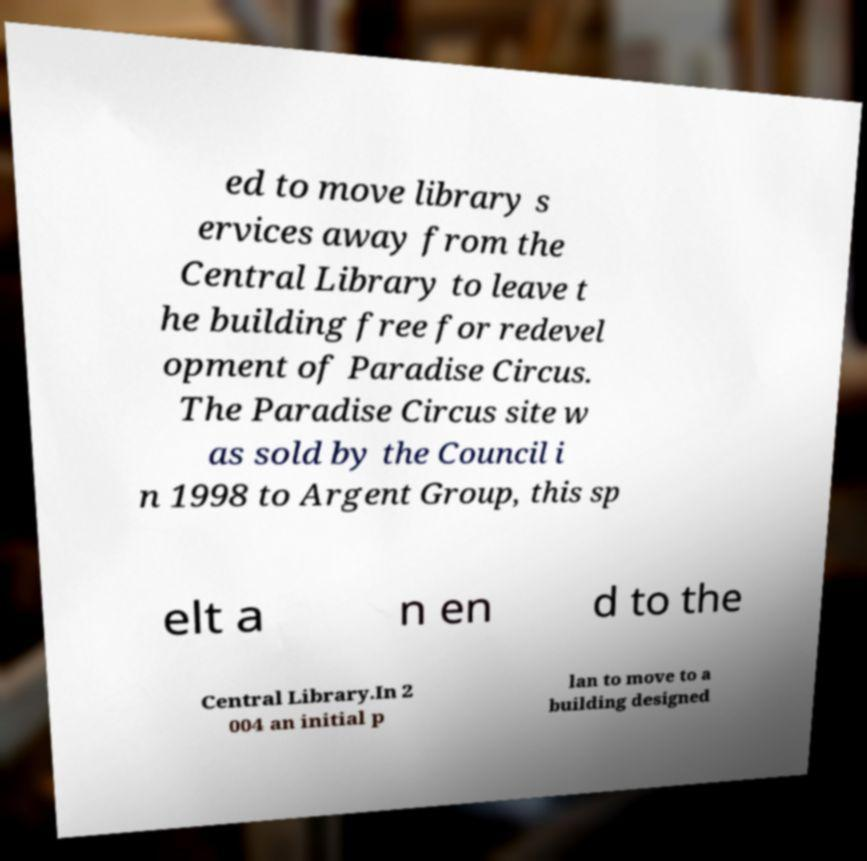I need the written content from this picture converted into text. Can you do that? ed to move library s ervices away from the Central Library to leave t he building free for redevel opment of Paradise Circus. The Paradise Circus site w as sold by the Council i n 1998 to Argent Group, this sp elt a n en d to the Central Library.In 2 004 an initial p lan to move to a building designed 